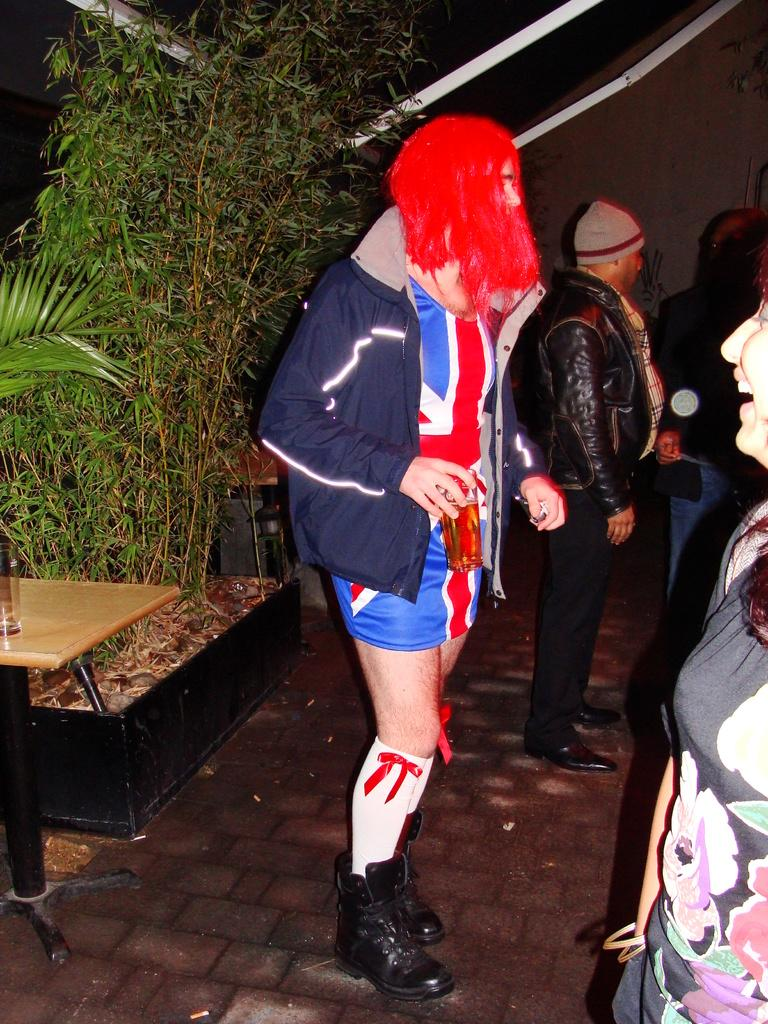What is happening in the image? There are people standing in the image. What can be seen in the background of the image? There are plants and a wall visible in the background. Where is the table located in the image? The table is to the left of the image. What is on the table? There is a glass on the table. What is the servant doing in the image? There is no servant present in the image. How does the glass affect the stomach of the people in the image? The image does not show any indication of the people's stomachs or how the glass might affect them. 